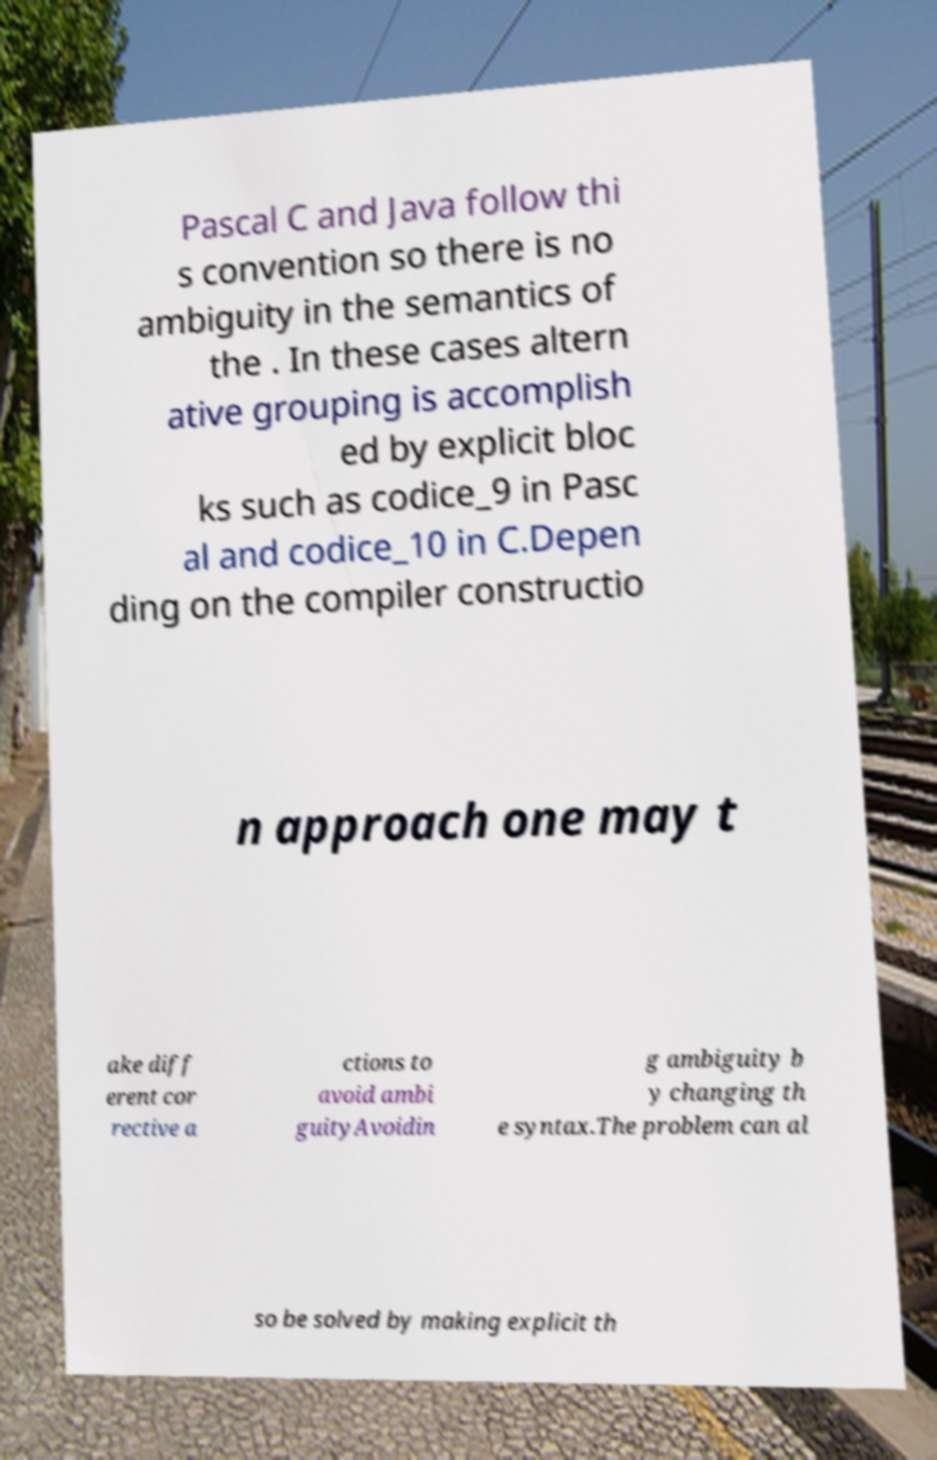There's text embedded in this image that I need extracted. Can you transcribe it verbatim? Pascal C and Java follow thi s convention so there is no ambiguity in the semantics of the . In these cases altern ative grouping is accomplish ed by explicit bloc ks such as codice_9 in Pasc al and codice_10 in C.Depen ding on the compiler constructio n approach one may t ake diff erent cor rective a ctions to avoid ambi guityAvoidin g ambiguity b y changing th e syntax.The problem can al so be solved by making explicit th 